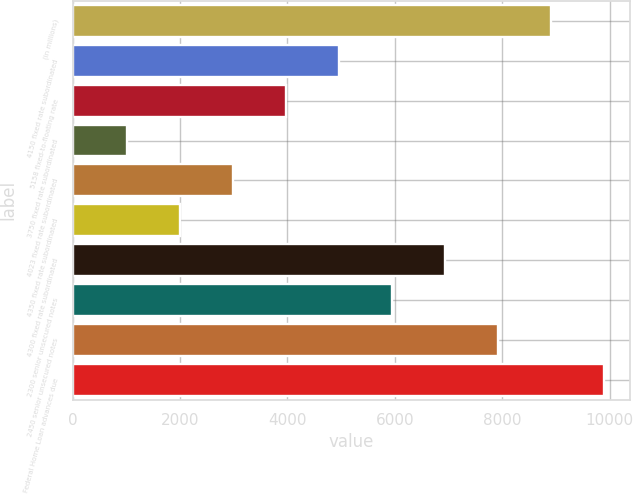Convert chart to OTSL. <chart><loc_0><loc_0><loc_500><loc_500><bar_chart><fcel>(in millions)<fcel>4150 fixed rate subordinated<fcel>5158 fixed-to-floating rate<fcel>3750 fixed rate subordinated<fcel>4023 fixed rate subordinated<fcel>4350 fixed rate subordinated<fcel>4300 fixed rate subordinated<fcel>2300 senior unsecured notes<fcel>2450 senior unsecured notes<fcel>Federal Home Loan advances due<nl><fcel>8899.9<fcel>4955.5<fcel>3969.4<fcel>1011.1<fcel>2983.3<fcel>1997.2<fcel>6927.7<fcel>5941.6<fcel>7913.8<fcel>9886<nl></chart> 